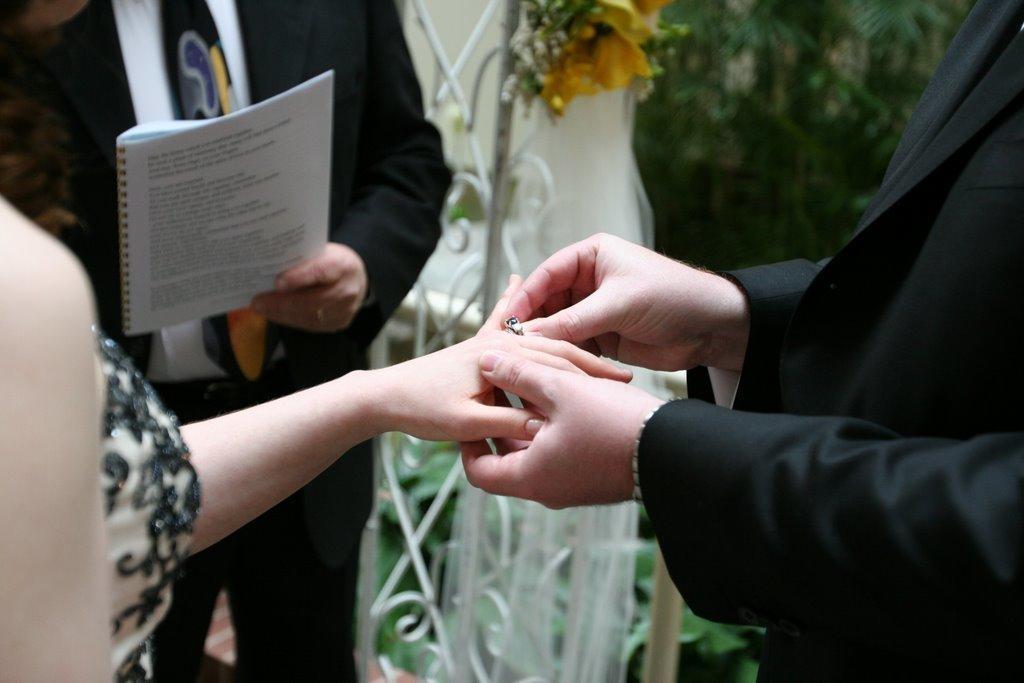How would you summarize this image in a sentence or two? In this image, we can see a man and woman hands. Man is holding a ring which is on woman's finger. Background greenery, person holding a book. 